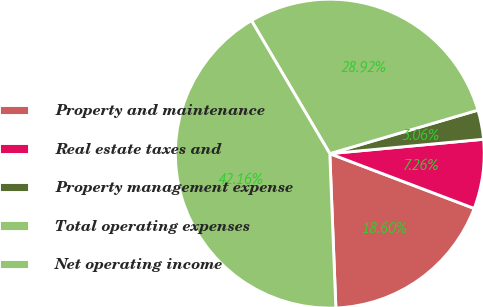Convert chart to OTSL. <chart><loc_0><loc_0><loc_500><loc_500><pie_chart><fcel>Property and maintenance<fcel>Real estate taxes and<fcel>Property management expense<fcel>Total operating expenses<fcel>Net operating income<nl><fcel>18.6%<fcel>7.26%<fcel>3.06%<fcel>28.92%<fcel>42.16%<nl></chart> 